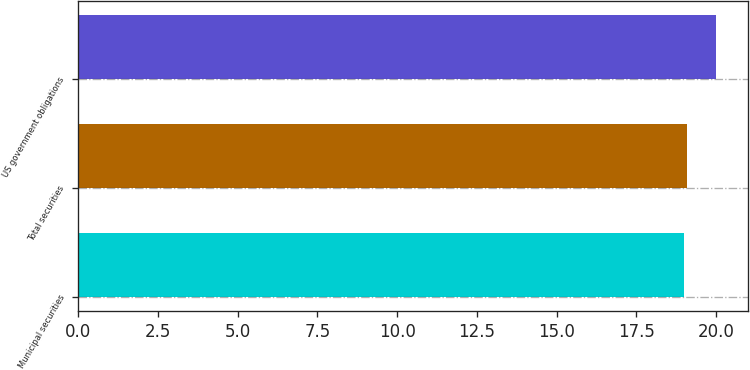Convert chart to OTSL. <chart><loc_0><loc_0><loc_500><loc_500><bar_chart><fcel>Municipal securities<fcel>Total securities<fcel>US government obligations<nl><fcel>19<fcel>19.1<fcel>20<nl></chart> 